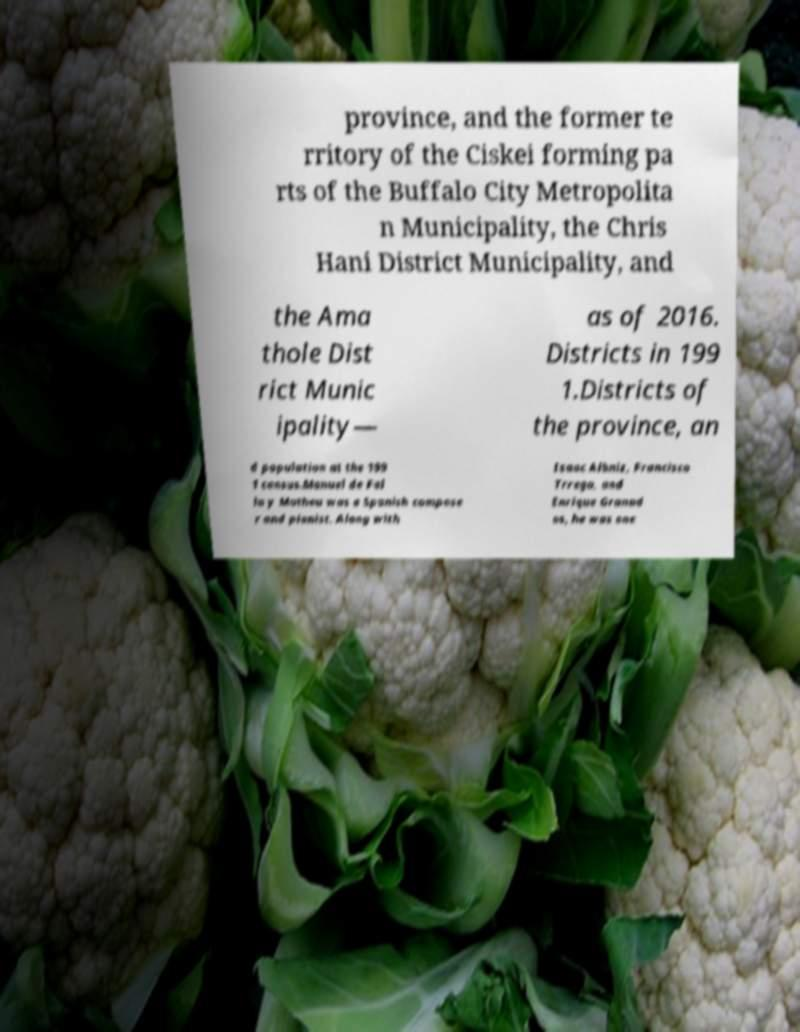I need the written content from this picture converted into text. Can you do that? province, and the former te rritory of the Ciskei forming pa rts of the Buffalo City Metropolita n Municipality, the Chris Hani District Municipality, and the Ama thole Dist rict Munic ipality— as of 2016. Districts in 199 1.Districts of the province, an d population at the 199 1 census.Manuel de Fal la y Matheu was a Spanish compose r and pianist. Along with Isaac Albniz, Francisco Trrega, and Enrique Granad os, he was one 